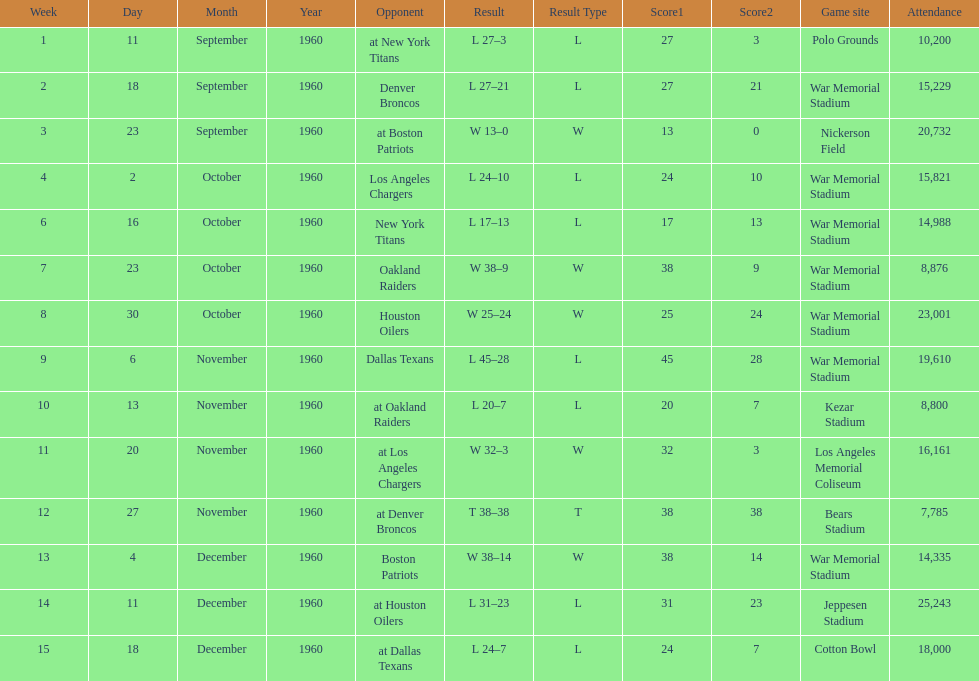What were the total number of games played in november? 4. 